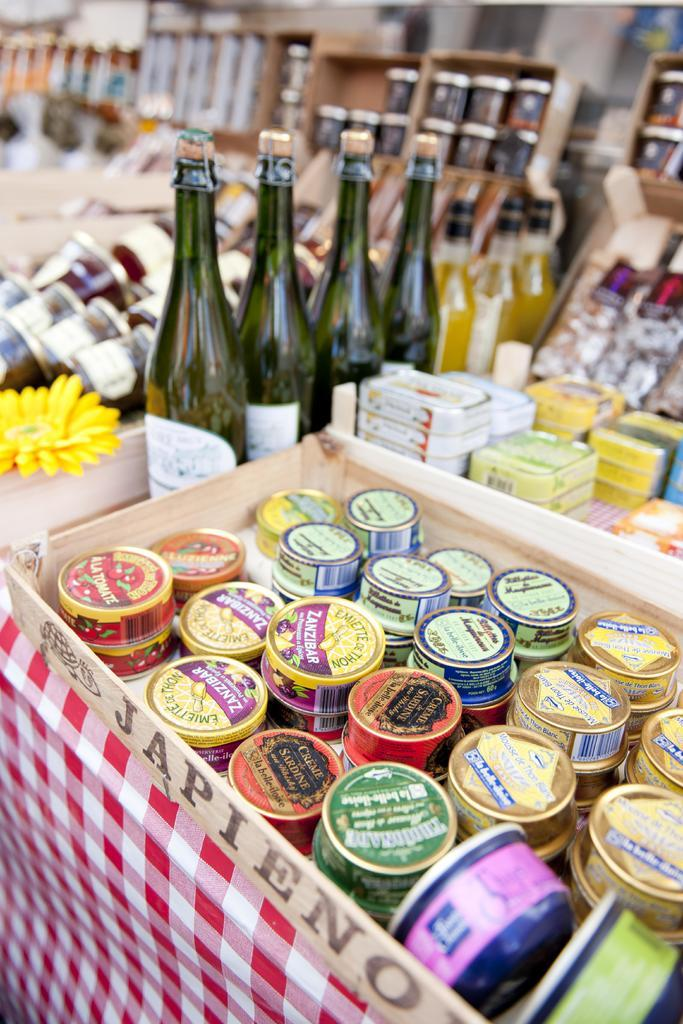<image>
Present a compact description of the photo's key features. Several small containers in a box with the word Japieno on its side. 